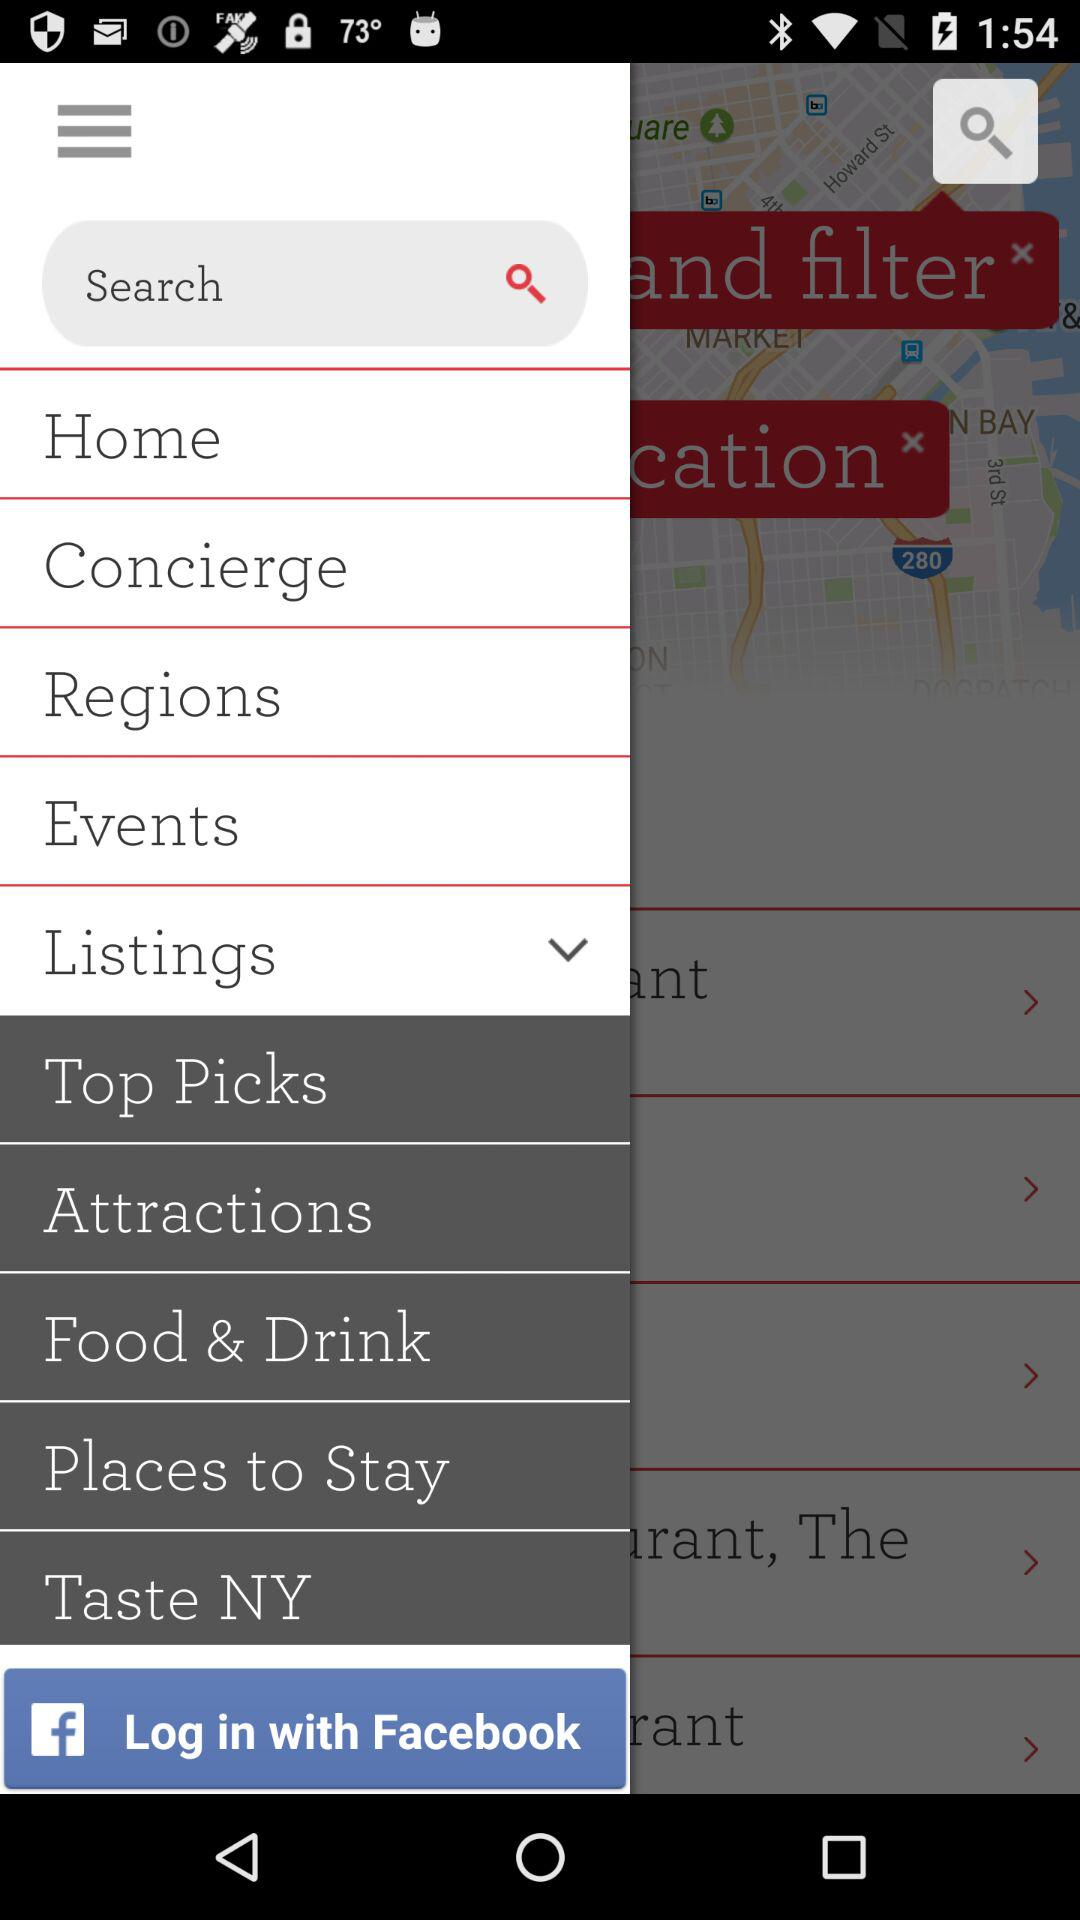How many text inputs are on the screen?
Answer the question using a single word or phrase. 1 